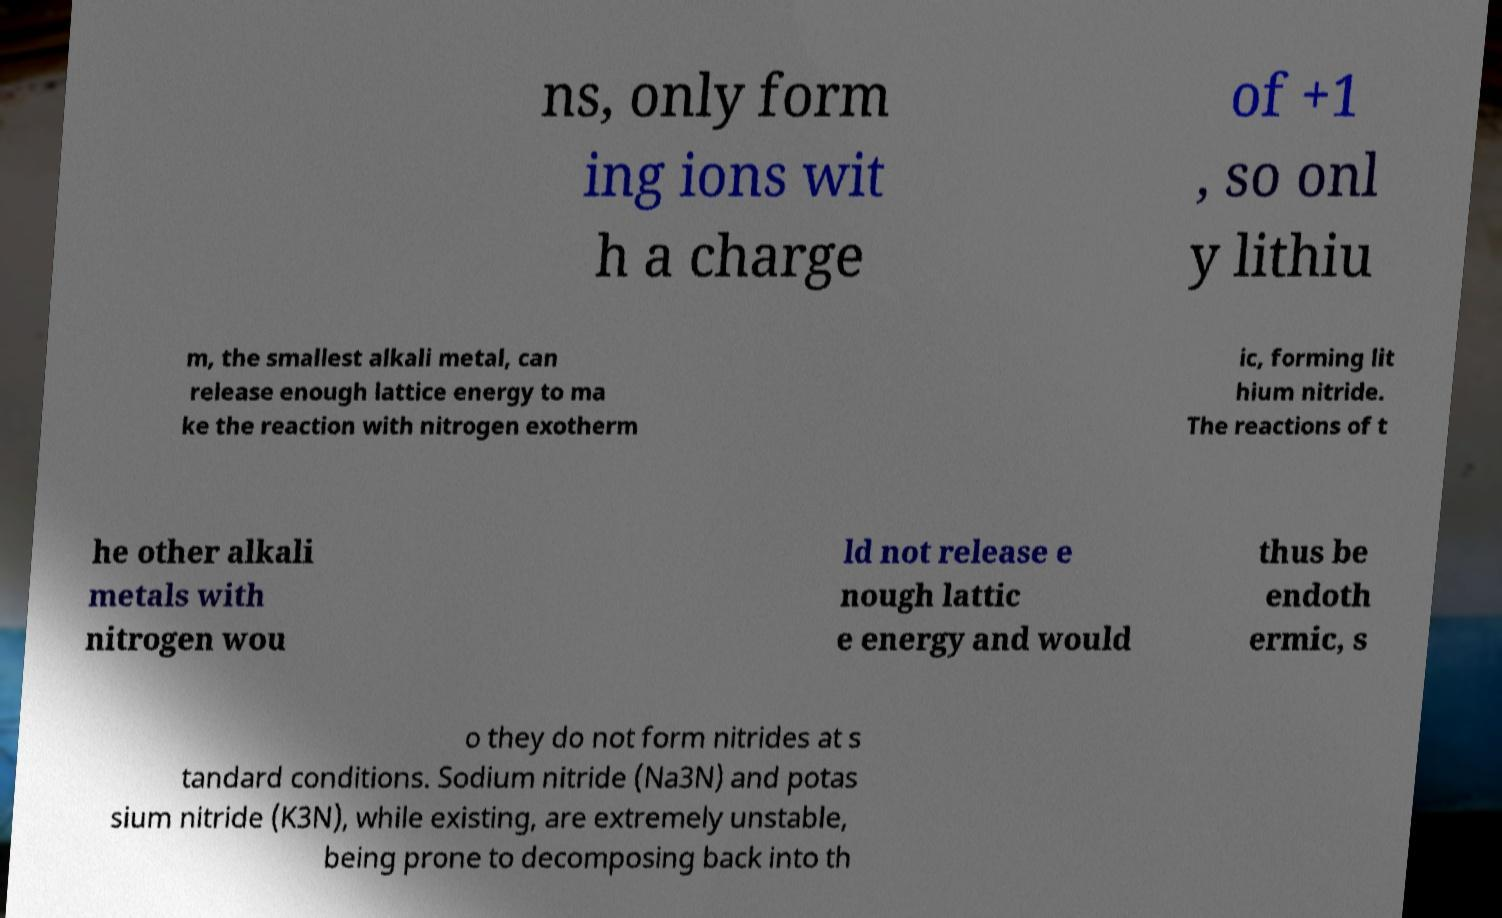Could you extract and type out the text from this image? ns, only form ing ions wit h a charge of +1 , so onl y lithiu m, the smallest alkali metal, can release enough lattice energy to ma ke the reaction with nitrogen exotherm ic, forming lit hium nitride. The reactions of t he other alkali metals with nitrogen wou ld not release e nough lattic e energy and would thus be endoth ermic, s o they do not form nitrides at s tandard conditions. Sodium nitride (Na3N) and potas sium nitride (K3N), while existing, are extremely unstable, being prone to decomposing back into th 